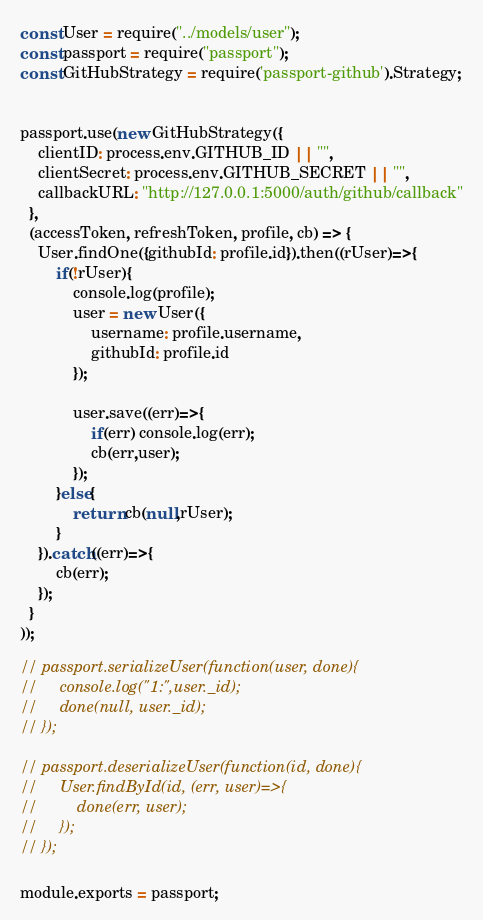<code> <loc_0><loc_0><loc_500><loc_500><_JavaScript_>const User = require("../models/user");
const passport = require("passport");
const GitHubStrategy = require('passport-github').Strategy;


passport.use(new GitHubStrategy({
    clientID: process.env.GITHUB_ID || "",
    clientSecret: process.env.GITHUB_SECRET || "",
    callbackURL: "http://127.0.0.1:5000/auth/github/callback"
  },
  (accessToken, refreshToken, profile, cb) => {
    User.findOne({githubId: profile.id}).then((rUser)=>{
        if(!rUser){
            console.log(profile);
            user = new User({
                username: profile.username,
                githubId: profile.id
            });

            user.save((err)=>{
                if(err) console.log(err);
                cb(err,user);
            });
        }else{
            return cb(null,rUser);
        }
    }).catch((err)=>{
        cb(err);
    });
  }
));

// passport.serializeUser(function(user, done){
//     console.log("1:",user._id);
//     done(null, user._id);
// });

// passport.deserializeUser(function(id, done){
//     User.findById(id, (err, user)=>{
//         done(err, user);
//     });
// });

module.exports = passport;</code> 